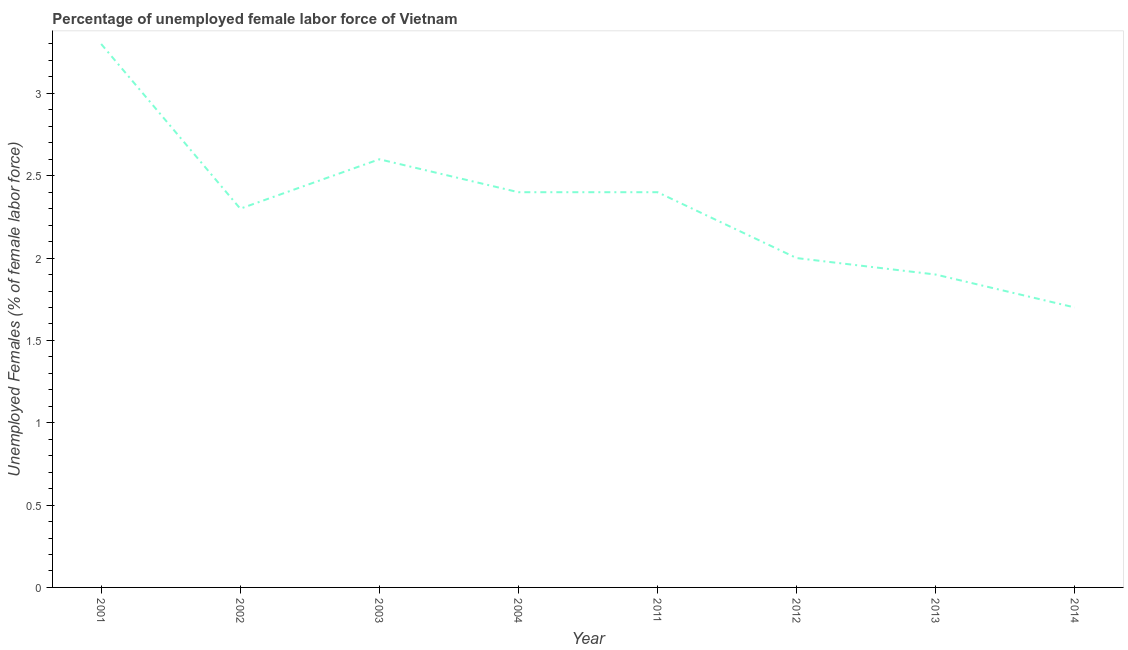What is the total unemployed female labour force in 2011?
Keep it short and to the point. 2.4. Across all years, what is the maximum total unemployed female labour force?
Your answer should be very brief. 3.3. Across all years, what is the minimum total unemployed female labour force?
Your answer should be compact. 1.7. In which year was the total unemployed female labour force minimum?
Offer a terse response. 2014. What is the sum of the total unemployed female labour force?
Give a very brief answer. 18.6. What is the difference between the total unemployed female labour force in 2003 and 2011?
Your response must be concise. 0.2. What is the average total unemployed female labour force per year?
Provide a short and direct response. 2.33. What is the median total unemployed female labour force?
Your answer should be compact. 2.35. What is the ratio of the total unemployed female labour force in 2001 to that in 2004?
Provide a short and direct response. 1.37. Is the total unemployed female labour force in 2011 less than that in 2013?
Ensure brevity in your answer.  No. Is the difference between the total unemployed female labour force in 2003 and 2012 greater than the difference between any two years?
Make the answer very short. No. What is the difference between the highest and the second highest total unemployed female labour force?
Give a very brief answer. 0.7. What is the difference between the highest and the lowest total unemployed female labour force?
Your answer should be compact. 1.6. How many lines are there?
Your answer should be very brief. 1. What is the difference between two consecutive major ticks on the Y-axis?
Provide a short and direct response. 0.5. Are the values on the major ticks of Y-axis written in scientific E-notation?
Ensure brevity in your answer.  No. Does the graph contain grids?
Provide a short and direct response. No. What is the title of the graph?
Provide a succinct answer. Percentage of unemployed female labor force of Vietnam. What is the label or title of the Y-axis?
Your answer should be very brief. Unemployed Females (% of female labor force). What is the Unemployed Females (% of female labor force) of 2001?
Your answer should be compact. 3.3. What is the Unemployed Females (% of female labor force) of 2002?
Keep it short and to the point. 2.3. What is the Unemployed Females (% of female labor force) of 2003?
Ensure brevity in your answer.  2.6. What is the Unemployed Females (% of female labor force) of 2004?
Provide a succinct answer. 2.4. What is the Unemployed Females (% of female labor force) in 2011?
Provide a short and direct response. 2.4. What is the Unemployed Females (% of female labor force) in 2013?
Offer a terse response. 1.9. What is the Unemployed Females (% of female labor force) in 2014?
Provide a succinct answer. 1.7. What is the difference between the Unemployed Females (% of female labor force) in 2001 and 2003?
Make the answer very short. 0.7. What is the difference between the Unemployed Females (% of female labor force) in 2001 and 2004?
Provide a short and direct response. 0.9. What is the difference between the Unemployed Females (% of female labor force) in 2001 and 2011?
Your answer should be compact. 0.9. What is the difference between the Unemployed Females (% of female labor force) in 2001 and 2013?
Offer a terse response. 1.4. What is the difference between the Unemployed Females (% of female labor force) in 2002 and 2004?
Offer a very short reply. -0.1. What is the difference between the Unemployed Females (% of female labor force) in 2002 and 2011?
Provide a short and direct response. -0.1. What is the difference between the Unemployed Females (% of female labor force) in 2002 and 2012?
Ensure brevity in your answer.  0.3. What is the difference between the Unemployed Females (% of female labor force) in 2002 and 2013?
Offer a very short reply. 0.4. What is the difference between the Unemployed Females (% of female labor force) in 2002 and 2014?
Offer a very short reply. 0.6. What is the difference between the Unemployed Females (% of female labor force) in 2003 and 2004?
Your answer should be very brief. 0.2. What is the difference between the Unemployed Females (% of female labor force) in 2003 and 2011?
Keep it short and to the point. 0.2. What is the difference between the Unemployed Females (% of female labor force) in 2003 and 2013?
Provide a succinct answer. 0.7. What is the difference between the Unemployed Females (% of female labor force) in 2004 and 2012?
Offer a terse response. 0.4. What is the difference between the Unemployed Females (% of female labor force) in 2004 and 2013?
Give a very brief answer. 0.5. What is the difference between the Unemployed Females (% of female labor force) in 2004 and 2014?
Provide a succinct answer. 0.7. What is the difference between the Unemployed Females (% of female labor force) in 2011 and 2013?
Make the answer very short. 0.5. What is the difference between the Unemployed Females (% of female labor force) in 2011 and 2014?
Make the answer very short. 0.7. What is the difference between the Unemployed Females (% of female labor force) in 2013 and 2014?
Make the answer very short. 0.2. What is the ratio of the Unemployed Females (% of female labor force) in 2001 to that in 2002?
Your response must be concise. 1.44. What is the ratio of the Unemployed Females (% of female labor force) in 2001 to that in 2003?
Make the answer very short. 1.27. What is the ratio of the Unemployed Females (% of female labor force) in 2001 to that in 2004?
Your answer should be very brief. 1.38. What is the ratio of the Unemployed Females (% of female labor force) in 2001 to that in 2011?
Offer a terse response. 1.38. What is the ratio of the Unemployed Females (% of female labor force) in 2001 to that in 2012?
Make the answer very short. 1.65. What is the ratio of the Unemployed Females (% of female labor force) in 2001 to that in 2013?
Offer a terse response. 1.74. What is the ratio of the Unemployed Females (% of female labor force) in 2001 to that in 2014?
Your answer should be compact. 1.94. What is the ratio of the Unemployed Females (% of female labor force) in 2002 to that in 2003?
Ensure brevity in your answer.  0.89. What is the ratio of the Unemployed Females (% of female labor force) in 2002 to that in 2004?
Your answer should be very brief. 0.96. What is the ratio of the Unemployed Females (% of female labor force) in 2002 to that in 2011?
Ensure brevity in your answer.  0.96. What is the ratio of the Unemployed Females (% of female labor force) in 2002 to that in 2012?
Provide a short and direct response. 1.15. What is the ratio of the Unemployed Females (% of female labor force) in 2002 to that in 2013?
Your response must be concise. 1.21. What is the ratio of the Unemployed Females (% of female labor force) in 2002 to that in 2014?
Ensure brevity in your answer.  1.35. What is the ratio of the Unemployed Females (% of female labor force) in 2003 to that in 2004?
Provide a short and direct response. 1.08. What is the ratio of the Unemployed Females (% of female labor force) in 2003 to that in 2011?
Ensure brevity in your answer.  1.08. What is the ratio of the Unemployed Females (% of female labor force) in 2003 to that in 2013?
Provide a short and direct response. 1.37. What is the ratio of the Unemployed Females (% of female labor force) in 2003 to that in 2014?
Offer a terse response. 1.53. What is the ratio of the Unemployed Females (% of female labor force) in 2004 to that in 2013?
Give a very brief answer. 1.26. What is the ratio of the Unemployed Females (% of female labor force) in 2004 to that in 2014?
Provide a succinct answer. 1.41. What is the ratio of the Unemployed Females (% of female labor force) in 2011 to that in 2013?
Offer a terse response. 1.26. What is the ratio of the Unemployed Females (% of female labor force) in 2011 to that in 2014?
Ensure brevity in your answer.  1.41. What is the ratio of the Unemployed Females (% of female labor force) in 2012 to that in 2013?
Your answer should be very brief. 1.05. What is the ratio of the Unemployed Females (% of female labor force) in 2012 to that in 2014?
Make the answer very short. 1.18. What is the ratio of the Unemployed Females (% of female labor force) in 2013 to that in 2014?
Your answer should be very brief. 1.12. 